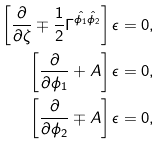Convert formula to latex. <formula><loc_0><loc_0><loc_500><loc_500>\left [ \frac { \partial } { \partial \zeta } \mp \frac { 1 } { 2 } \Gamma ^ { \hat { \phi _ { 1 } } \hat { \phi _ { 2 } } } \right ] \epsilon & = 0 , \\ \left [ \frac { \partial } { \partial \phi _ { 1 } } + A \right ] \epsilon & = 0 , \\ \left [ \frac { \partial } { \partial \phi _ { 2 } } \mp A \right ] \epsilon & = 0 ,</formula> 